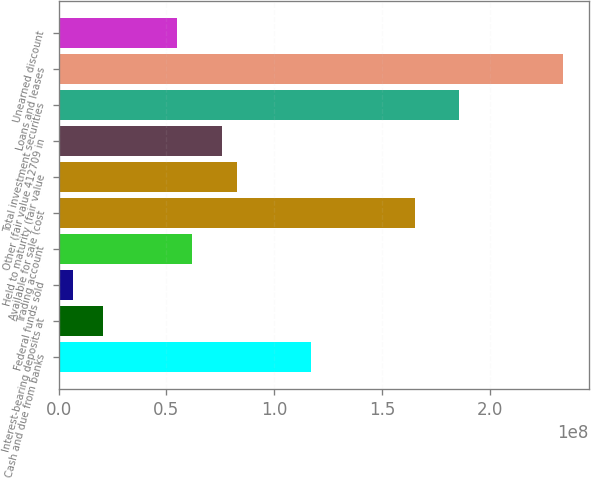Convert chart. <chart><loc_0><loc_0><loc_500><loc_500><bar_chart><fcel>Cash and due from banks<fcel>Interest-bearing deposits at<fcel>Federal funds sold<fcel>Trading account<fcel>Available for sale (cost<fcel>Held to maturity (fair value<fcel>Other (fair value 412709 in<fcel>Total investment securities<fcel>Loans and leases<fcel>Unearned discount<nl><fcel>1.17094e+08<fcel>2.06672e+07<fcel>6.89195e+06<fcel>6.19928e+07<fcel>1.65307e+08<fcel>8.26556e+07<fcel>7.5768e+07<fcel>1.8597e+08<fcel>2.34183e+08<fcel>5.51052e+07<nl></chart> 